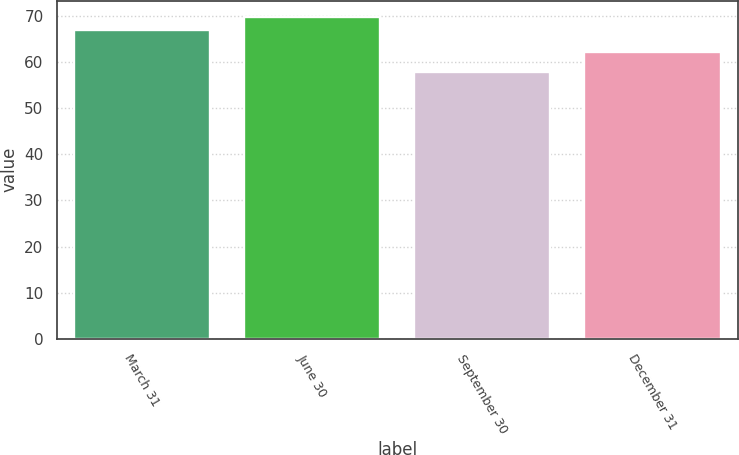<chart> <loc_0><loc_0><loc_500><loc_500><bar_chart><fcel>March 31<fcel>June 30<fcel>September 30<fcel>December 31<nl><fcel>66.84<fcel>69.74<fcel>57.83<fcel>62.18<nl></chart> 